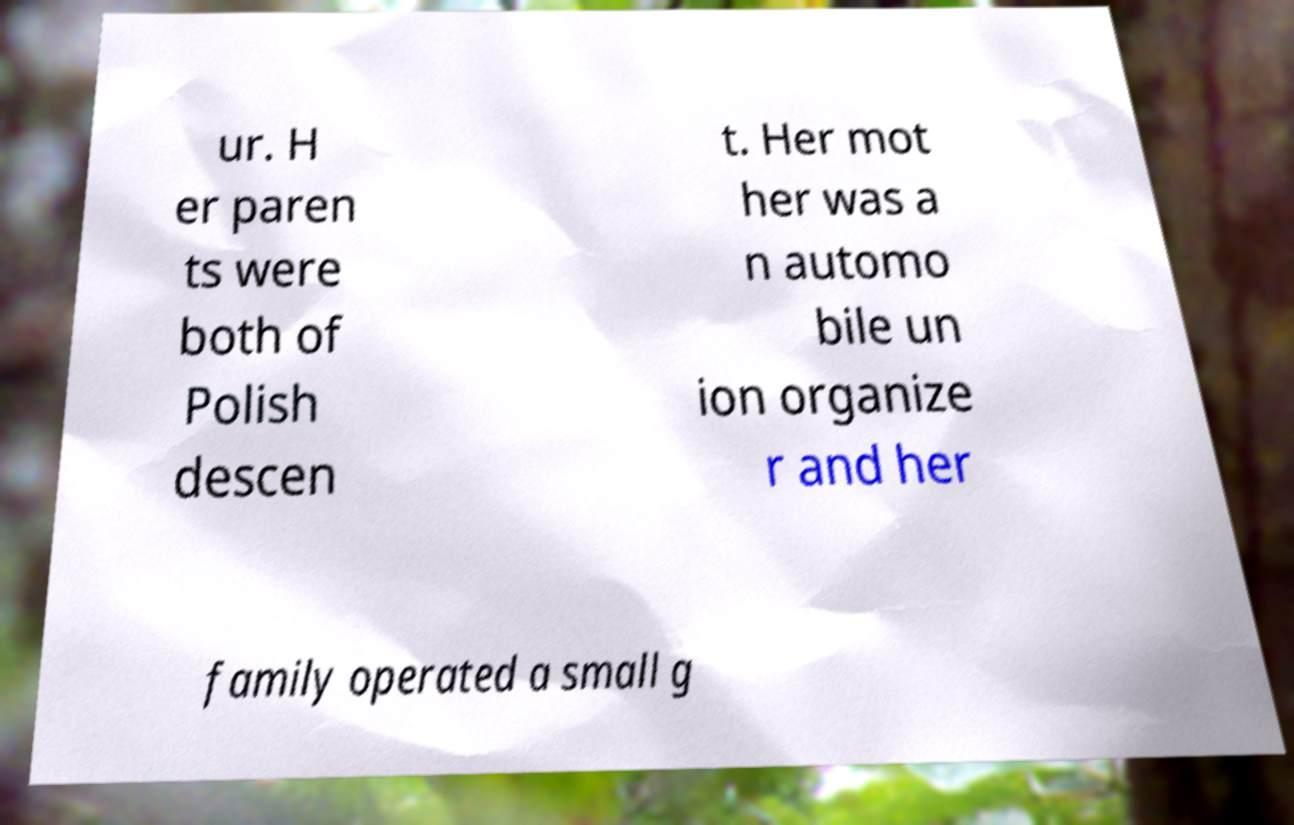Please read and relay the text visible in this image. What does it say? ur. H er paren ts were both of Polish descen t. Her mot her was a n automo bile un ion organize r and her family operated a small g 